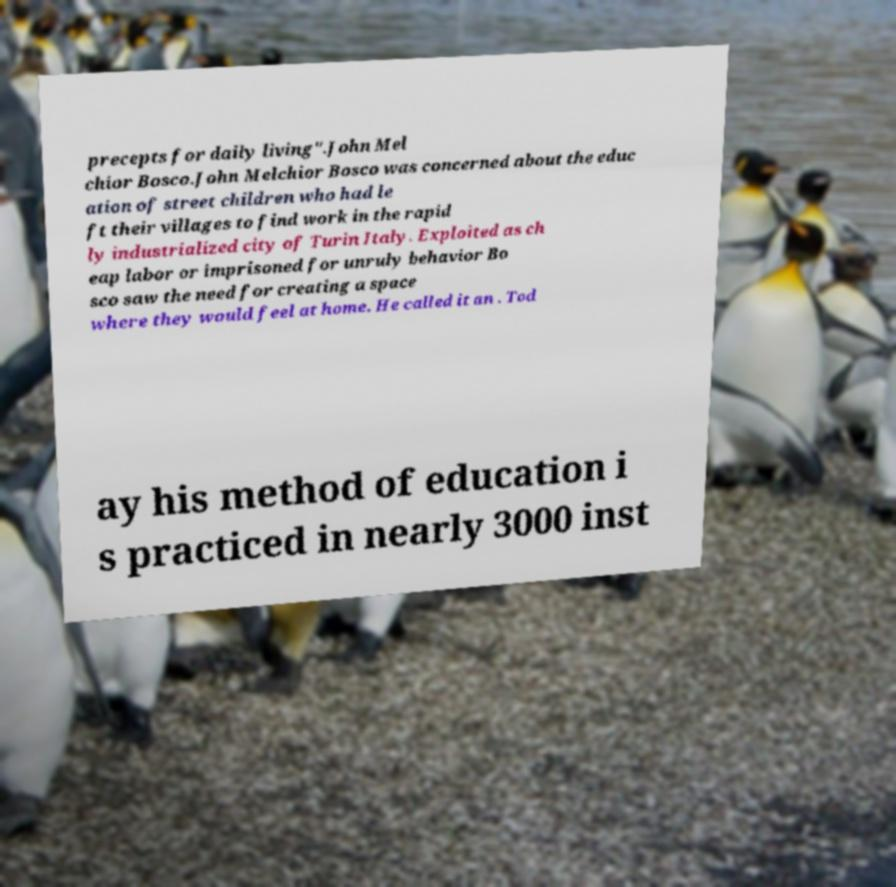For documentation purposes, I need the text within this image transcribed. Could you provide that? precepts for daily living".John Mel chior Bosco.John Melchior Bosco was concerned about the educ ation of street children who had le ft their villages to find work in the rapid ly industrialized city of Turin Italy. Exploited as ch eap labor or imprisoned for unruly behavior Bo sco saw the need for creating a space where they would feel at home. He called it an . Tod ay his method of education i s practiced in nearly 3000 inst 